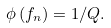Convert formula to latex. <formula><loc_0><loc_0><loc_500><loc_500>\phi \left ( f _ { n } \right ) = 1 / Q .</formula> 